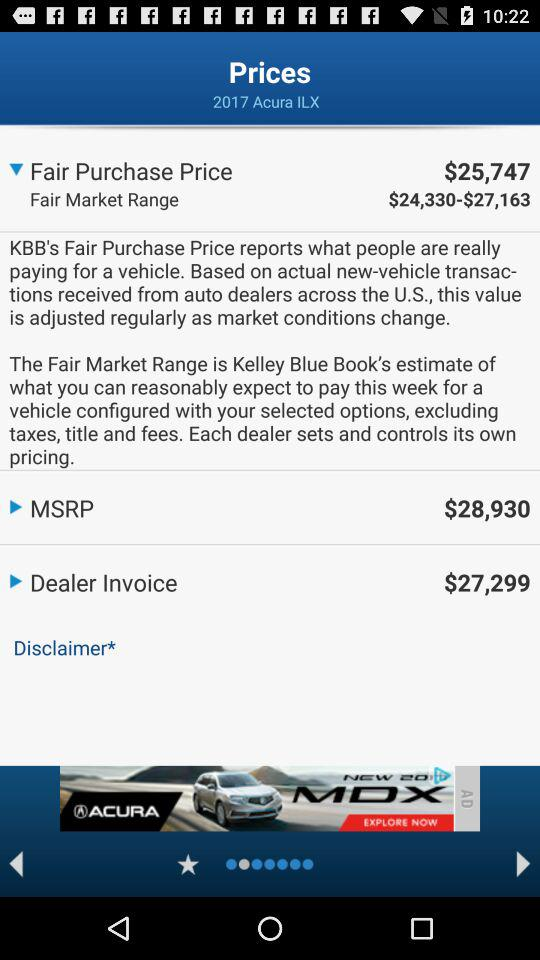What is MSRP?
Answer the question using a single word or phrase. It is $28,930. 